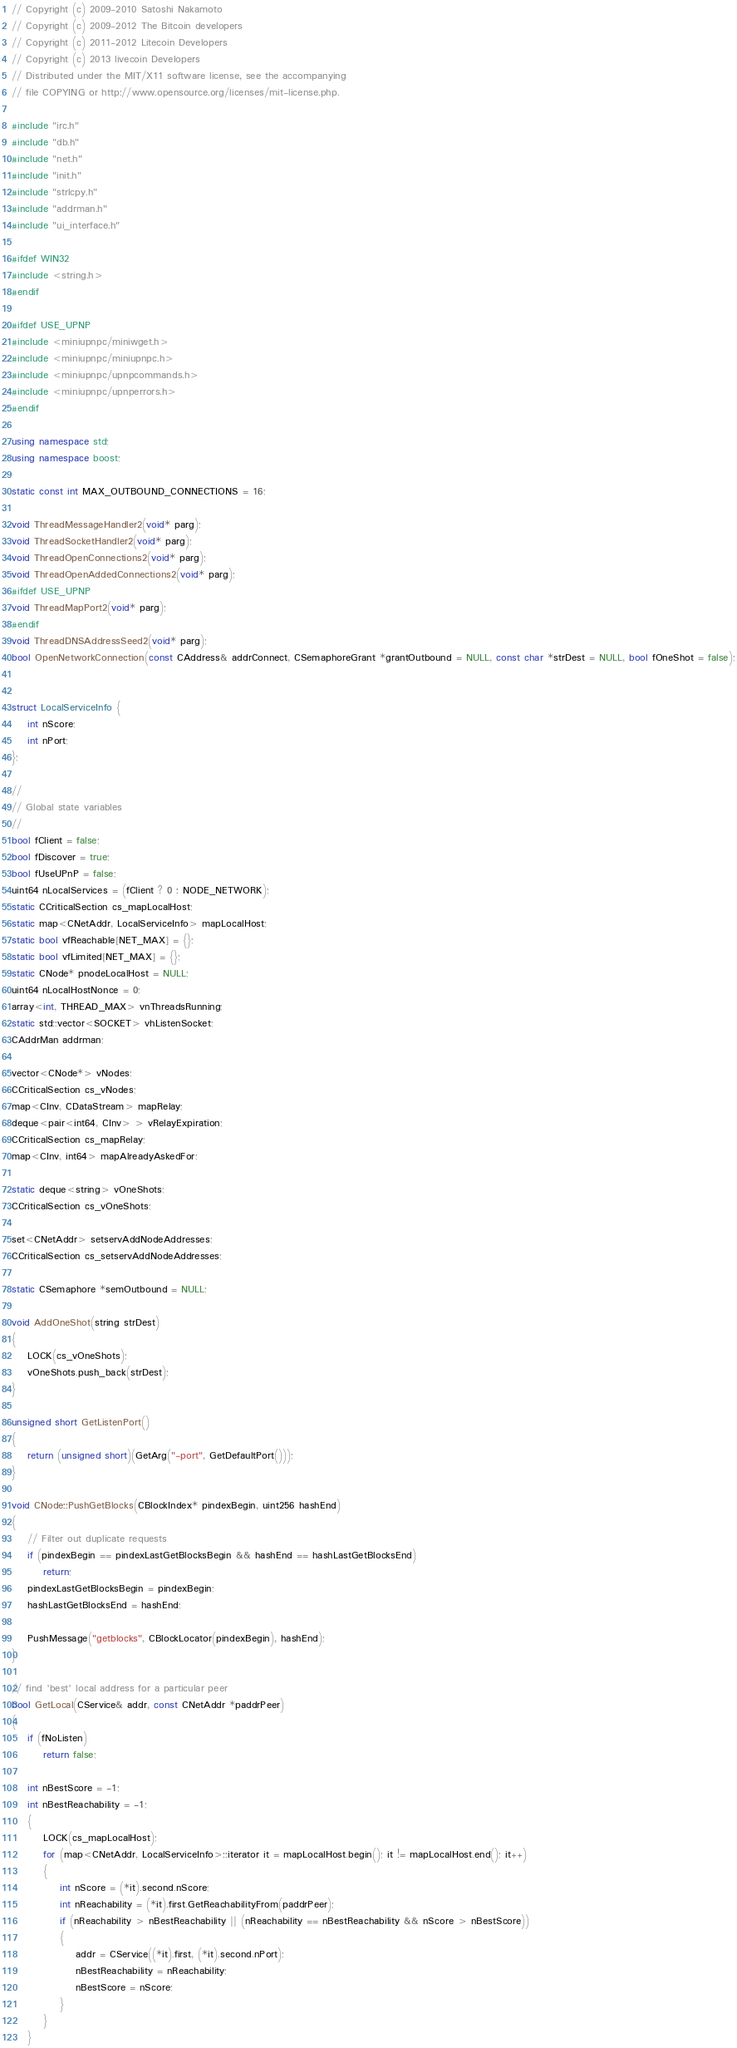<code> <loc_0><loc_0><loc_500><loc_500><_C++_>// Copyright (c) 2009-2010 Satoshi Nakamoto
// Copyright (c) 2009-2012 The Bitcoin developers
// Copyright (c) 2011-2012 Litecoin Developers
// Copyright (c) 2013 livecoin Developers
// Distributed under the MIT/X11 software license, see the accompanying
// file COPYING or http://www.opensource.org/licenses/mit-license.php.

#include "irc.h"
#include "db.h"
#include "net.h"
#include "init.h"
#include "strlcpy.h"
#include "addrman.h"
#include "ui_interface.h"

#ifdef WIN32
#include <string.h>
#endif

#ifdef USE_UPNP
#include <miniupnpc/miniwget.h>
#include <miniupnpc/miniupnpc.h>
#include <miniupnpc/upnpcommands.h>
#include <miniupnpc/upnperrors.h>
#endif

using namespace std;
using namespace boost;

static const int MAX_OUTBOUND_CONNECTIONS = 16;

void ThreadMessageHandler2(void* parg);
void ThreadSocketHandler2(void* parg);
void ThreadOpenConnections2(void* parg);
void ThreadOpenAddedConnections2(void* parg);
#ifdef USE_UPNP
void ThreadMapPort2(void* parg);
#endif
void ThreadDNSAddressSeed2(void* parg);
bool OpenNetworkConnection(const CAddress& addrConnect, CSemaphoreGrant *grantOutbound = NULL, const char *strDest = NULL, bool fOneShot = false);


struct LocalServiceInfo {
    int nScore;
    int nPort;
};

//
// Global state variables
//
bool fClient = false;
bool fDiscover = true;
bool fUseUPnP = false;
uint64 nLocalServices = (fClient ? 0 : NODE_NETWORK);
static CCriticalSection cs_mapLocalHost;
static map<CNetAddr, LocalServiceInfo> mapLocalHost;
static bool vfReachable[NET_MAX] = {};
static bool vfLimited[NET_MAX] = {};
static CNode* pnodeLocalHost = NULL;
uint64 nLocalHostNonce = 0;
array<int, THREAD_MAX> vnThreadsRunning;
static std::vector<SOCKET> vhListenSocket;
CAddrMan addrman;

vector<CNode*> vNodes;
CCriticalSection cs_vNodes;
map<CInv, CDataStream> mapRelay;
deque<pair<int64, CInv> > vRelayExpiration;
CCriticalSection cs_mapRelay;
map<CInv, int64> mapAlreadyAskedFor;

static deque<string> vOneShots;
CCriticalSection cs_vOneShots;

set<CNetAddr> setservAddNodeAddresses;
CCriticalSection cs_setservAddNodeAddresses;

static CSemaphore *semOutbound = NULL;

void AddOneShot(string strDest)
{
    LOCK(cs_vOneShots);
    vOneShots.push_back(strDest);
}

unsigned short GetListenPort()
{
    return (unsigned short)(GetArg("-port", GetDefaultPort()));
}

void CNode::PushGetBlocks(CBlockIndex* pindexBegin, uint256 hashEnd)
{
    // Filter out duplicate requests
    if (pindexBegin == pindexLastGetBlocksBegin && hashEnd == hashLastGetBlocksEnd)
        return;
    pindexLastGetBlocksBegin = pindexBegin;
    hashLastGetBlocksEnd = hashEnd;

    PushMessage("getblocks", CBlockLocator(pindexBegin), hashEnd);
}

// find 'best' local address for a particular peer
bool GetLocal(CService& addr, const CNetAddr *paddrPeer)
{
    if (fNoListen)
        return false;

    int nBestScore = -1;
    int nBestReachability = -1;
    {
        LOCK(cs_mapLocalHost);
        for (map<CNetAddr, LocalServiceInfo>::iterator it = mapLocalHost.begin(); it != mapLocalHost.end(); it++)
        {
            int nScore = (*it).second.nScore;
            int nReachability = (*it).first.GetReachabilityFrom(paddrPeer);
            if (nReachability > nBestReachability || (nReachability == nBestReachability && nScore > nBestScore))
            {
                addr = CService((*it).first, (*it).second.nPort);
                nBestReachability = nReachability;
                nBestScore = nScore;
            }
        }
    }</code> 